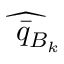<formula> <loc_0><loc_0><loc_500><loc_500>\widehat { \bar { q } _ { B _ { k } } }</formula> 